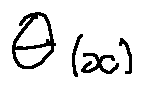<formula> <loc_0><loc_0><loc_500><loc_500>\theta ( x )</formula> 